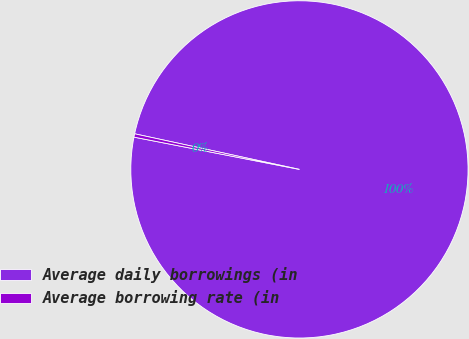Convert chart. <chart><loc_0><loc_0><loc_500><loc_500><pie_chart><fcel>Average daily borrowings (in<fcel>Average borrowing rate (in<nl><fcel>99.68%<fcel>0.32%<nl></chart> 